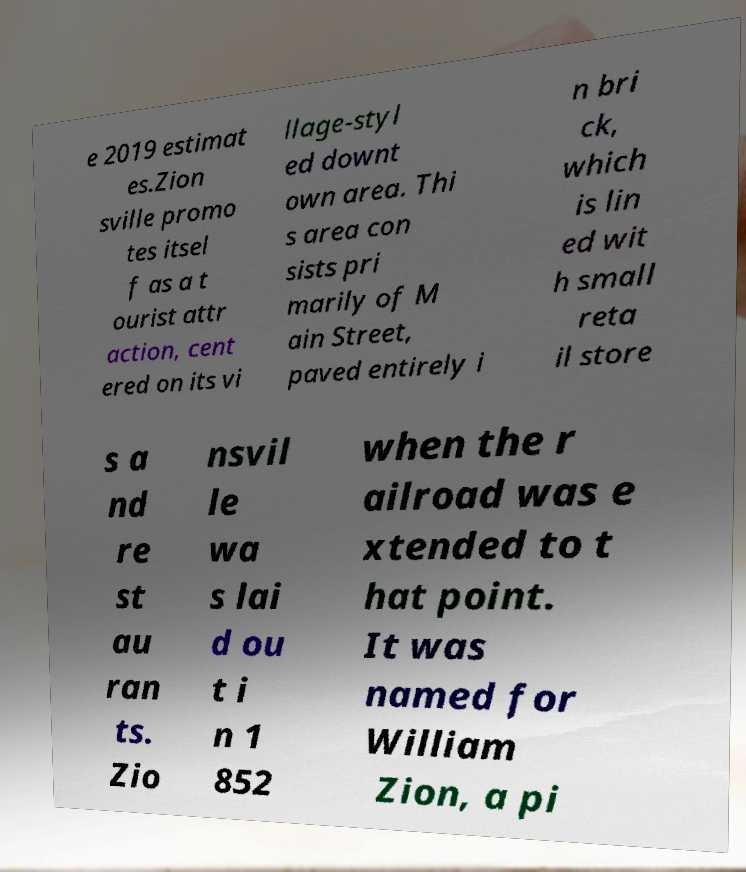Could you assist in decoding the text presented in this image and type it out clearly? e 2019 estimat es.Zion sville promo tes itsel f as a t ourist attr action, cent ered on its vi llage-styl ed downt own area. Thi s area con sists pri marily of M ain Street, paved entirely i n bri ck, which is lin ed wit h small reta il store s a nd re st au ran ts. Zio nsvil le wa s lai d ou t i n 1 852 when the r ailroad was e xtended to t hat point. It was named for William Zion, a pi 